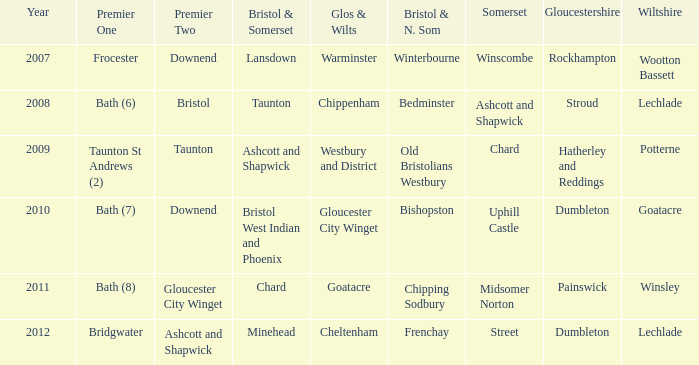What is the bristol & n. som location where somerset includes ashcott and shapwick? Bedminster. 